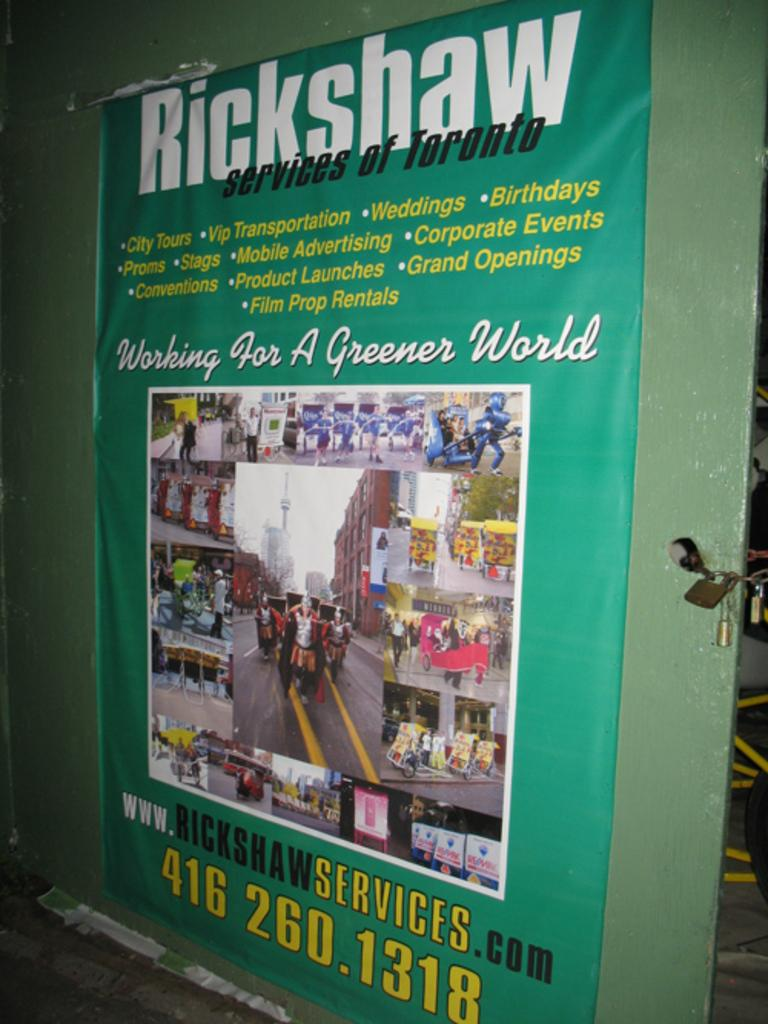<image>
Relay a brief, clear account of the picture shown. A poster advertising Rickshaw services of Toronto and has a phone number and website on it 